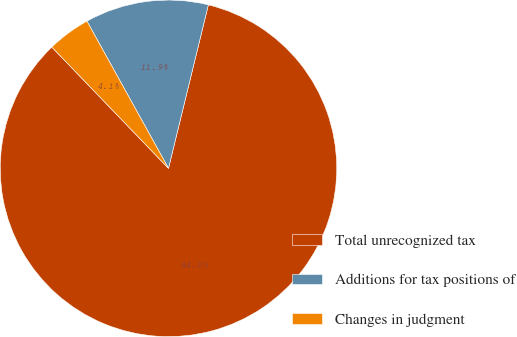Convert chart to OTSL. <chart><loc_0><loc_0><loc_500><loc_500><pie_chart><fcel>Total unrecognized tax<fcel>Additions for tax positions of<fcel>Changes in judgment<nl><fcel>83.99%<fcel>11.86%<fcel>4.14%<nl></chart> 